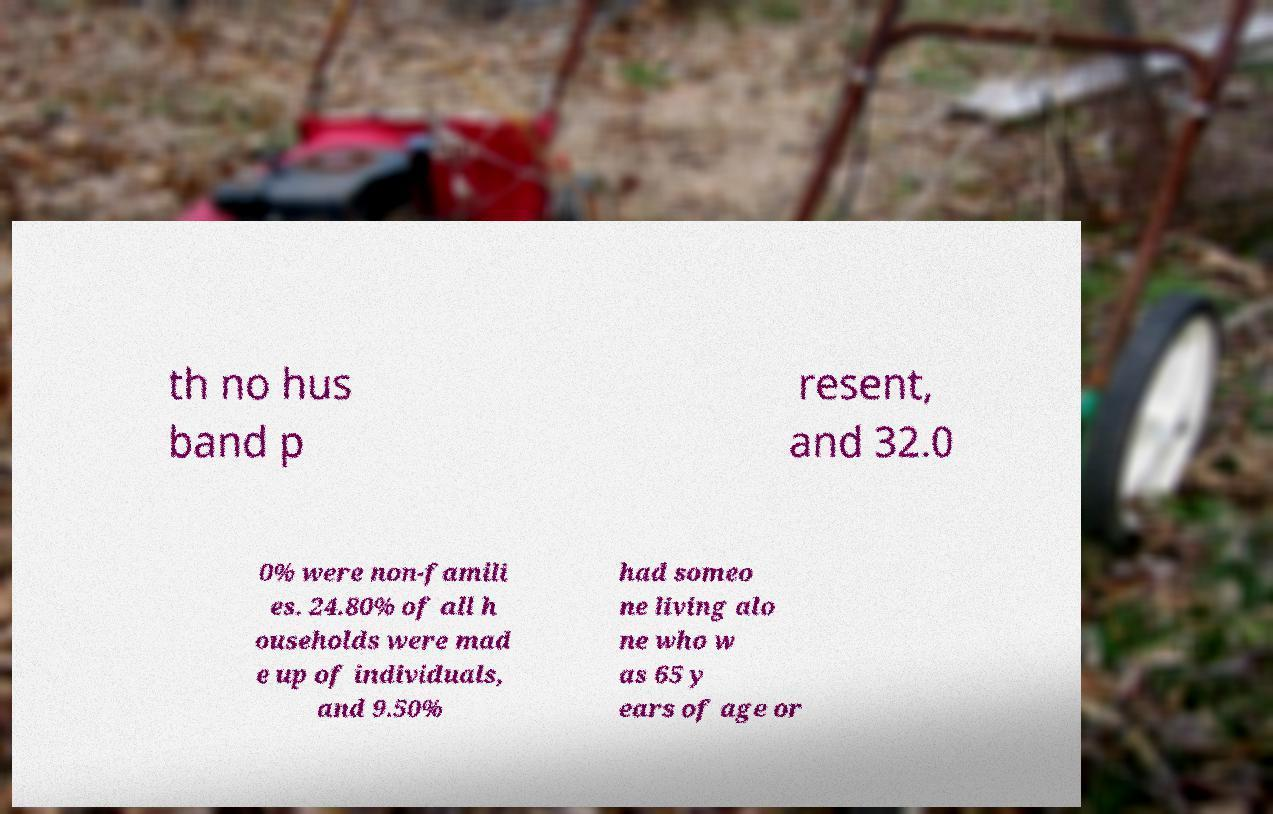There's text embedded in this image that I need extracted. Can you transcribe it verbatim? th no hus band p resent, and 32.0 0% were non-famili es. 24.80% of all h ouseholds were mad e up of individuals, and 9.50% had someo ne living alo ne who w as 65 y ears of age or 